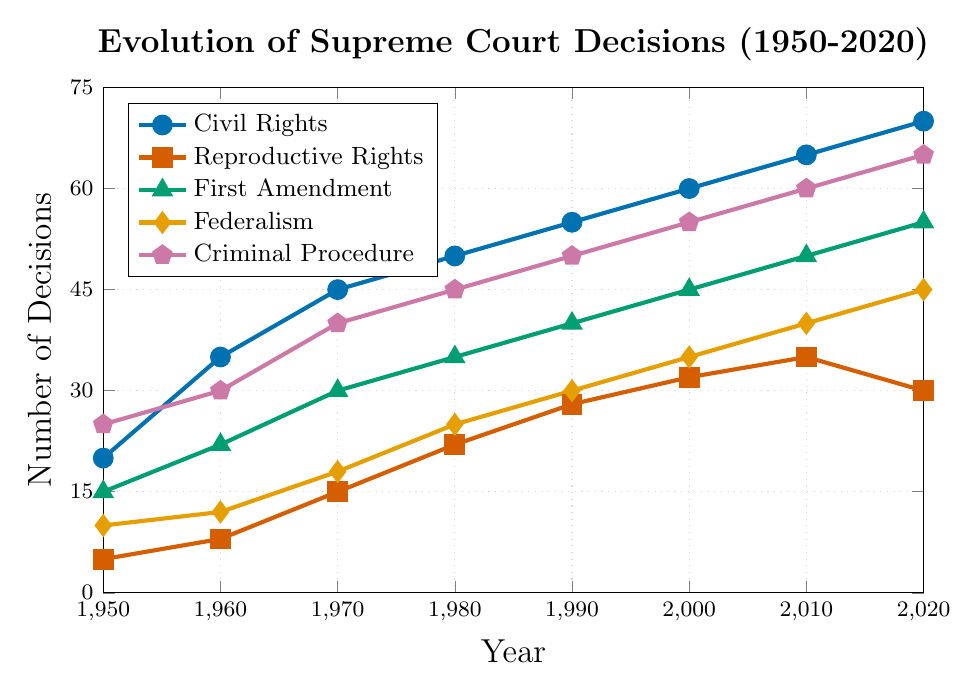Which category saw the greatest increase in the number of decisions from 1950 to 2020? To find the category with the greatest increase, we subtract the 1950 value from the 2020 value for each category: Civil Rights (70-20=50), Reproductive Rights (30-5=25), First Amendment (55-15=40), Federalism (45-10=35), Criminal Procedure (65-25=40). The category with the highest increase is Civil Rights.
Answer: Civil Rights What is the difference in the number of decisions related to Civil Rights and Reproductive Rights in 2020? To find the difference, subtract the number of Reproductive Rights decisions in 2020 from the number of Civil Rights decisions in 2020: 70 - 30 = 40.
Answer: 40 Which years have the same number of decisions for Criminal Procedure and Federalism? We look at the data points for Criminal Procedure and Federalism across the years: There are no years where both have the same number of decisions.
Answer: None In which decade(s) did the number of First Amendment decisions increase by the largest amount? To find the decade with the largest increase, we calculate the difference for each decade. 1950s (22-15=7), 1960s (30-22=8), 1970s (35-30=5), 1980s (40-35=5), 1990s (45-40=5), 2000s (50-45=5), 2010s (55-50=5). The greatest increase is in the 1960s with an increase of 8.
Answer: 1960s If you average the number of decisions for Civil Rights over the decades, what is the value? Sum up the Civil Rights decisions across the years: 20 + 35 + 45 + 50 + 55 + 60 + 65 + 70 = 400. Then divide by the number of data points (8). 400 / 8 = 50.
Answer: 50 How did the number of Reproductive Rights decisions change from 2010 to 2020? Subtract the number of Reproductive Rights decisions in 2020 from the number in 2010: 30 - 35 = -5. This shows a decrease of 5 decisions.
Answer: Decrease by 5 Which category had the highest number of decisions in 1980? Look at the data for 1980: Civil Rights (50), Reproductive Rights (22), First Amendment (35), Federalism (25), Criminal Procedure (45). The highest number is Criminal Procedure with 45.
Answer: Criminal Procedure What’s the total number of decisions across all categories in 1970? Sum the decisions for each category in 1970: 45 (Civil Rights) + 15 (Reproductive Rights) + 30 (First Amendment) + 18 (Federalism) + 40 (Criminal Procedure) = 148.
Answer: 148 Which category experienced a decrease in the number of decisions from 2010 to 2020? Compare the 2010 and 2020 values: Civil Rights (65 to 70), Reproductive Rights (35 to 30), First Amendment (50 to 55), Federalism (40 to 45), Criminal Procedure (60 to 65). Only Reproductive Rights decreased from 35 to 30.
Answer: Reproductive Rights Which category had the most consistent increase across the decades? To find the most consistent increase, we examine the incremental changes per decade. Civil Rights: {15, 10, 5, 5, 5, 5, 5}, Reproductive Rights: {3, 7, 7, 6, 4, 3, -5}, First Amendment: {7, 8, 5, 5, 5, 5, 5}, Federalism: {2, 6, 7, 5, 5, 5, 5}, Criminal Procedure: {5, 10, 5, 5, 5, 5, 5}. Civil Rights and First Amendment have the most consistent incremental changes of 5 in the later decades.
Answer: Civil Rights, First Amendment 